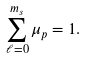<formula> <loc_0><loc_0><loc_500><loc_500>\sum _ { \ell = 0 } ^ { m _ { s } } \mu _ { p } = 1 .</formula> 